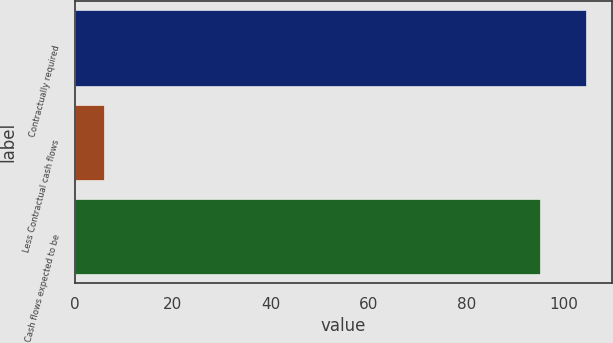Convert chart to OTSL. <chart><loc_0><loc_0><loc_500><loc_500><bar_chart><fcel>Contractually required<fcel>Less Contractual cash flows<fcel>Cash flows expected to be<nl><fcel>104.5<fcel>6<fcel>95<nl></chart> 